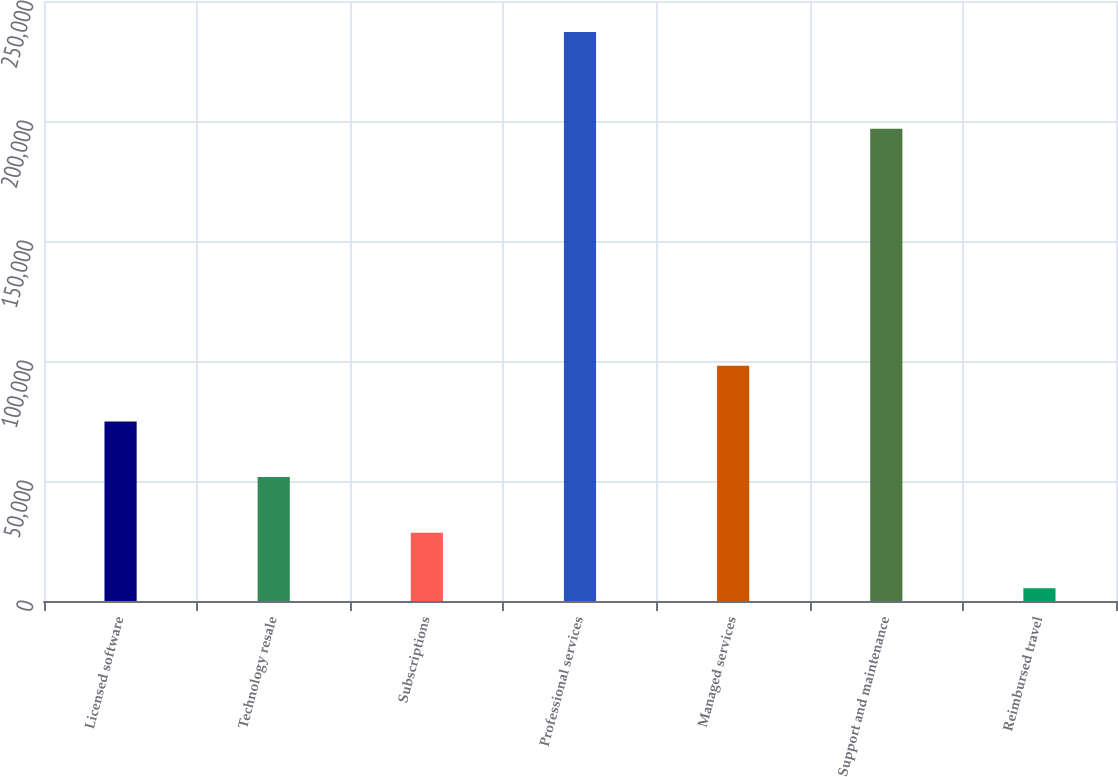Convert chart to OTSL. <chart><loc_0><loc_0><loc_500><loc_500><bar_chart><fcel>Licensed software<fcel>Technology resale<fcel>Subscriptions<fcel>Professional services<fcel>Managed services<fcel>Support and maintenance<fcel>Reimbursed travel<nl><fcel>74834.5<fcel>51660<fcel>28485.5<fcel>237056<fcel>98009<fcel>196780<fcel>5311<nl></chart> 